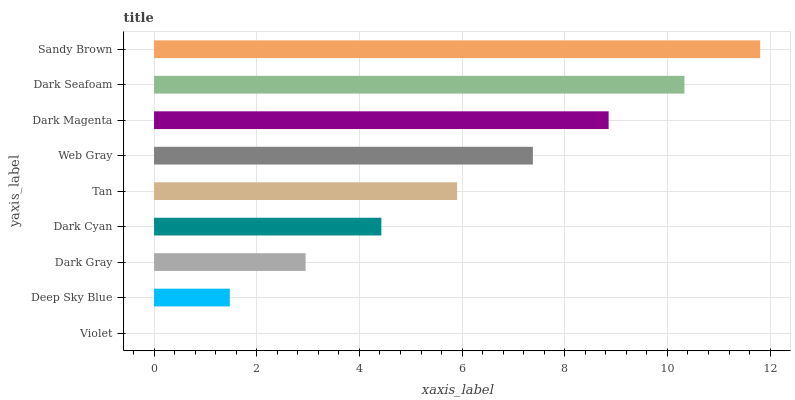Is Violet the minimum?
Answer yes or no. Yes. Is Sandy Brown the maximum?
Answer yes or no. Yes. Is Deep Sky Blue the minimum?
Answer yes or no. No. Is Deep Sky Blue the maximum?
Answer yes or no. No. Is Deep Sky Blue greater than Violet?
Answer yes or no. Yes. Is Violet less than Deep Sky Blue?
Answer yes or no. Yes. Is Violet greater than Deep Sky Blue?
Answer yes or no. No. Is Deep Sky Blue less than Violet?
Answer yes or no. No. Is Tan the high median?
Answer yes or no. Yes. Is Tan the low median?
Answer yes or no. Yes. Is Deep Sky Blue the high median?
Answer yes or no. No. Is Web Gray the low median?
Answer yes or no. No. 